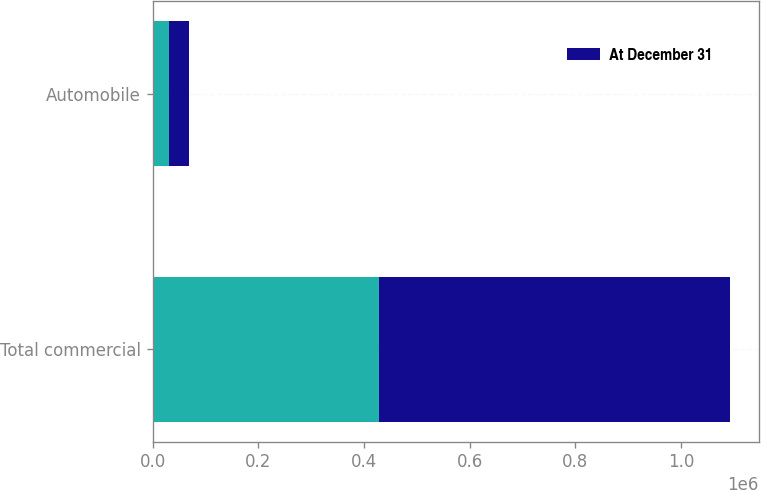Convert chart to OTSL. <chart><loc_0><loc_0><loc_500><loc_500><stacked_bar_chart><ecel><fcel>Total commercial<fcel>Automobile<nl><fcel>nan<fcel>428358<fcel>31053<nl><fcel>At December 31<fcel>664073<fcel>38282<nl></chart> 